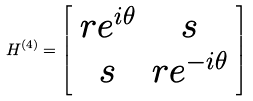<formula> <loc_0><loc_0><loc_500><loc_500>H ^ { ( 4 ) } = \left [ \begin{array} { c c } r e ^ { i \theta } & s \\ s & r e ^ { - i \theta } \\ \end{array} \right ]</formula> 